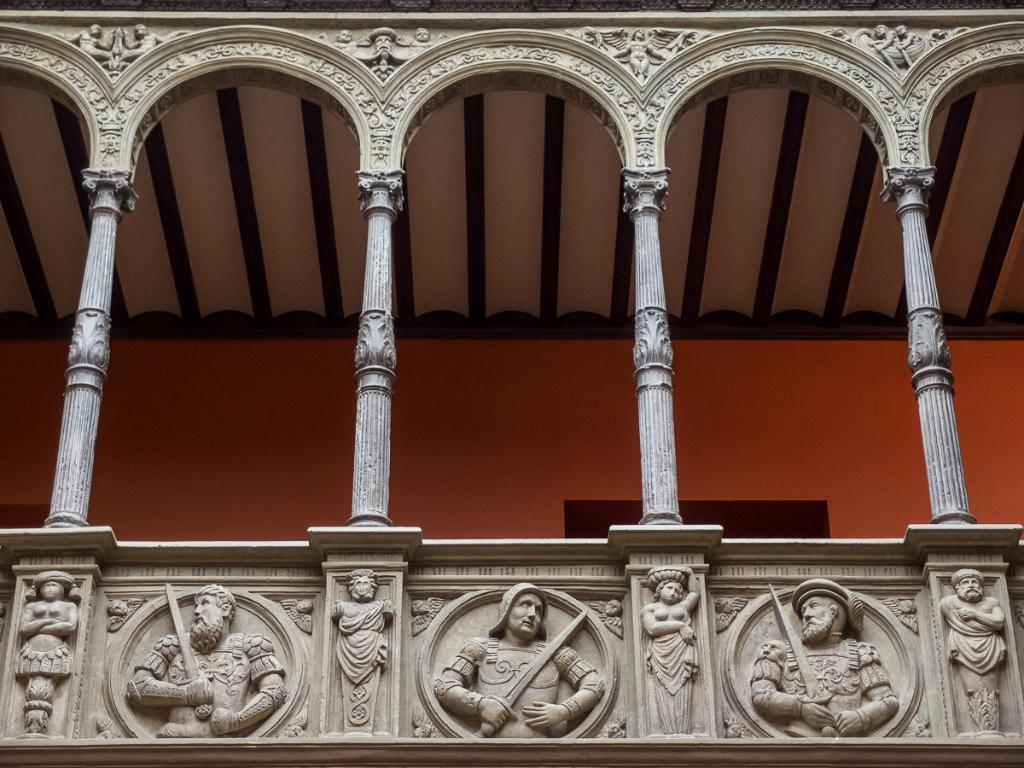What type of structure is visible in the image? There is a wall and a roof visible in the image, which suggests a building or house. Are there any architectural features present in the image? Yes, there are pillars in the image. What can be seen on the walls in the image? There are carvings on the walls in the image. How many eggs are being used to make the boot in the image? There is no boot or eggs present in the image. What type of skate is depicted on the wall in the image? There is no skate present in the image; it features carvings on the walls. 